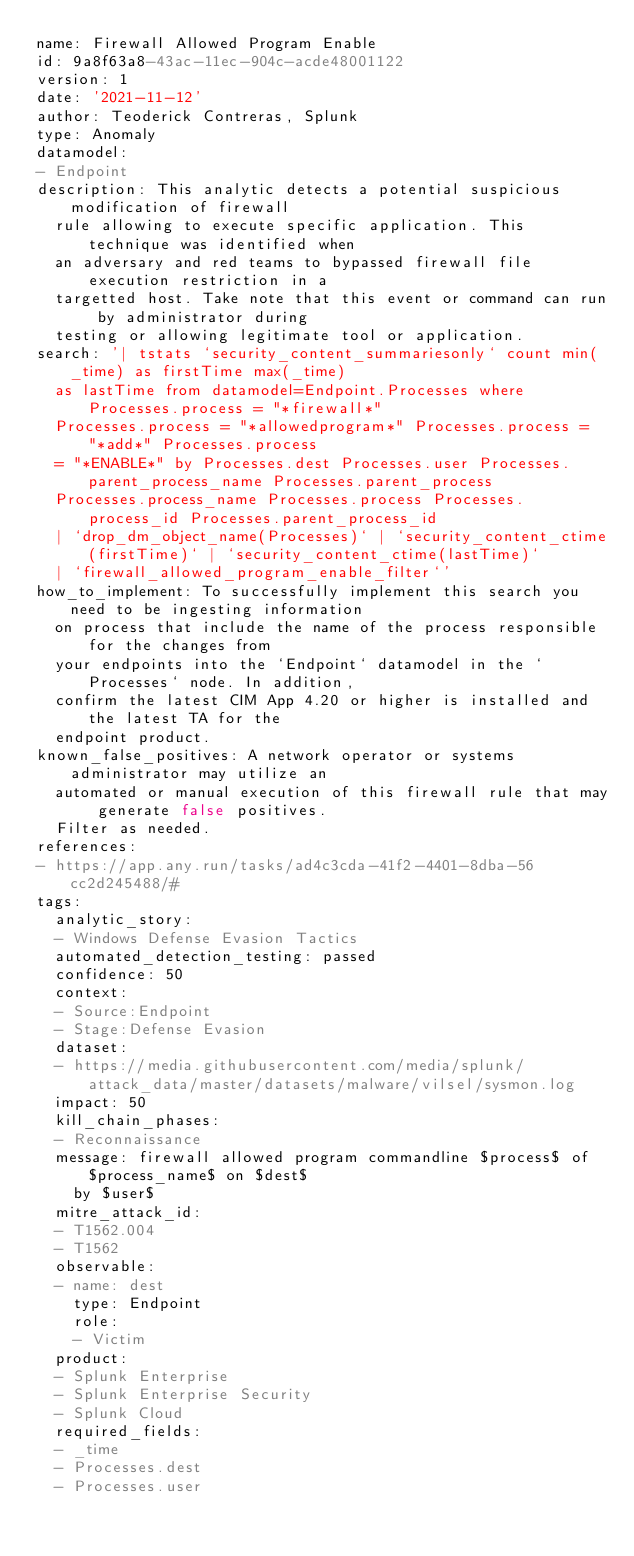Convert code to text. <code><loc_0><loc_0><loc_500><loc_500><_YAML_>name: Firewall Allowed Program Enable
id: 9a8f63a8-43ac-11ec-904c-acde48001122
version: 1
date: '2021-11-12'
author: Teoderick Contreras, Splunk
type: Anomaly
datamodel:
- Endpoint
description: This analytic detects a potential suspicious modification of firewall
  rule allowing to execute specific application. This technique was identified when
  an adversary and red teams to bypassed firewall file execution restriction in a
  targetted host. Take note that this event or command can run by administrator during
  testing or allowing legitimate tool or application.
search: '| tstats `security_content_summariesonly` count min(_time) as firstTime max(_time)
  as lastTime from datamodel=Endpoint.Processes where Processes.process = "*firewall*"
  Processes.process = "*allowedprogram*" Processes.process = "*add*" Processes.process
  = "*ENABLE*" by Processes.dest Processes.user Processes.parent_process_name Processes.parent_process
  Processes.process_name Processes.process Processes.process_id Processes.parent_process_id
  | `drop_dm_object_name(Processes)` | `security_content_ctime(firstTime)` | `security_content_ctime(lastTime)`
  | `firewall_allowed_program_enable_filter`'
how_to_implement: To successfully implement this search you need to be ingesting information
  on process that include the name of the process responsible for the changes from
  your endpoints into the `Endpoint` datamodel in the `Processes` node. In addition,
  confirm the latest CIM App 4.20 or higher is installed and the latest TA for the
  endpoint product.
known_false_positives: A network operator or systems administrator may utilize an
  automated or manual execution of this firewall rule that may generate false positives.
  Filter as needed.
references:
- https://app.any.run/tasks/ad4c3cda-41f2-4401-8dba-56cc2d245488/#
tags:
  analytic_story:
  - Windows Defense Evasion Tactics
  automated_detection_testing: passed
  confidence: 50
  context:
  - Source:Endpoint
  - Stage:Defense Evasion
  dataset:
  - https://media.githubusercontent.com/media/splunk/attack_data/master/datasets/malware/vilsel/sysmon.log
  impact: 50
  kill_chain_phases:
  - Reconnaissance
  message: firewall allowed program commandline $process$ of $process_name$ on $dest$
    by $user$
  mitre_attack_id:
  - T1562.004
  - T1562
  observable:
  - name: dest
    type: Endpoint
    role:
    - Victim
  product:
  - Splunk Enterprise
  - Splunk Enterprise Security
  - Splunk Cloud
  required_fields:
  - _time
  - Processes.dest
  - Processes.user</code> 